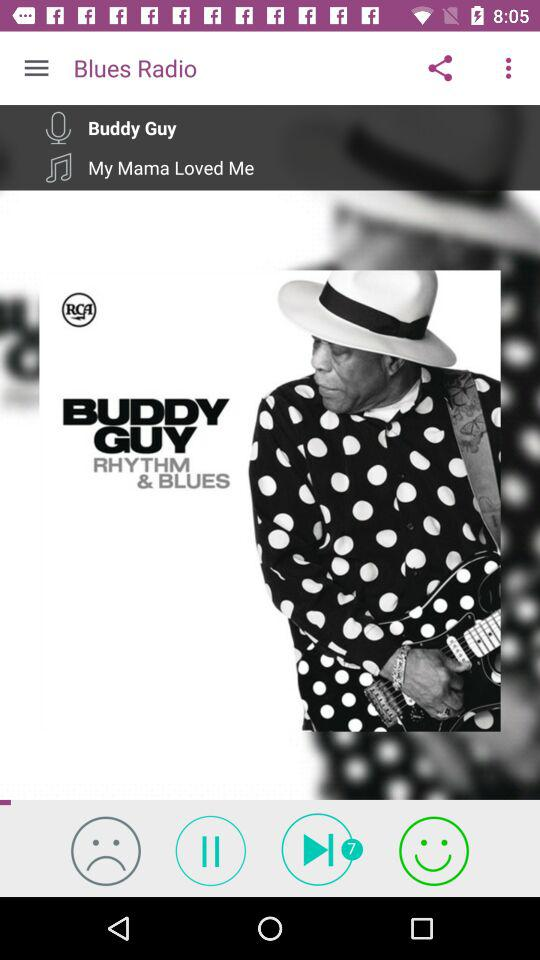What is the name of the song? The name of the song is My Mama Loved Me. 